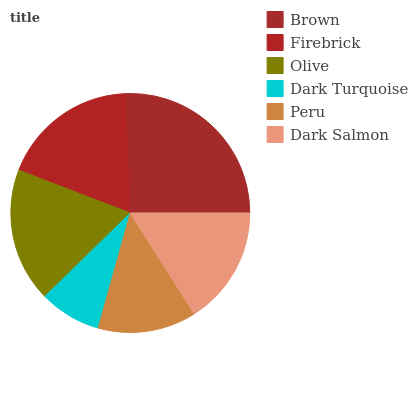Is Dark Turquoise the minimum?
Answer yes or no. Yes. Is Brown the maximum?
Answer yes or no. Yes. Is Firebrick the minimum?
Answer yes or no. No. Is Firebrick the maximum?
Answer yes or no. No. Is Brown greater than Firebrick?
Answer yes or no. Yes. Is Firebrick less than Brown?
Answer yes or no. Yes. Is Firebrick greater than Brown?
Answer yes or no. No. Is Brown less than Firebrick?
Answer yes or no. No. Is Olive the high median?
Answer yes or no. Yes. Is Dark Salmon the low median?
Answer yes or no. Yes. Is Dark Salmon the high median?
Answer yes or no. No. Is Dark Turquoise the low median?
Answer yes or no. No. 